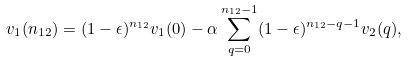<formula> <loc_0><loc_0><loc_500><loc_500>v _ { 1 } ( n _ { 1 2 } ) = ( 1 - \epsilon ) ^ { n _ { 1 2 } } v _ { 1 } ( 0 ) - \alpha \sum _ { q = 0 } ^ { n _ { 1 2 } - 1 } ( 1 - \epsilon ) ^ { n _ { 1 2 } - q - 1 } v _ { 2 } ( q ) ,</formula> 